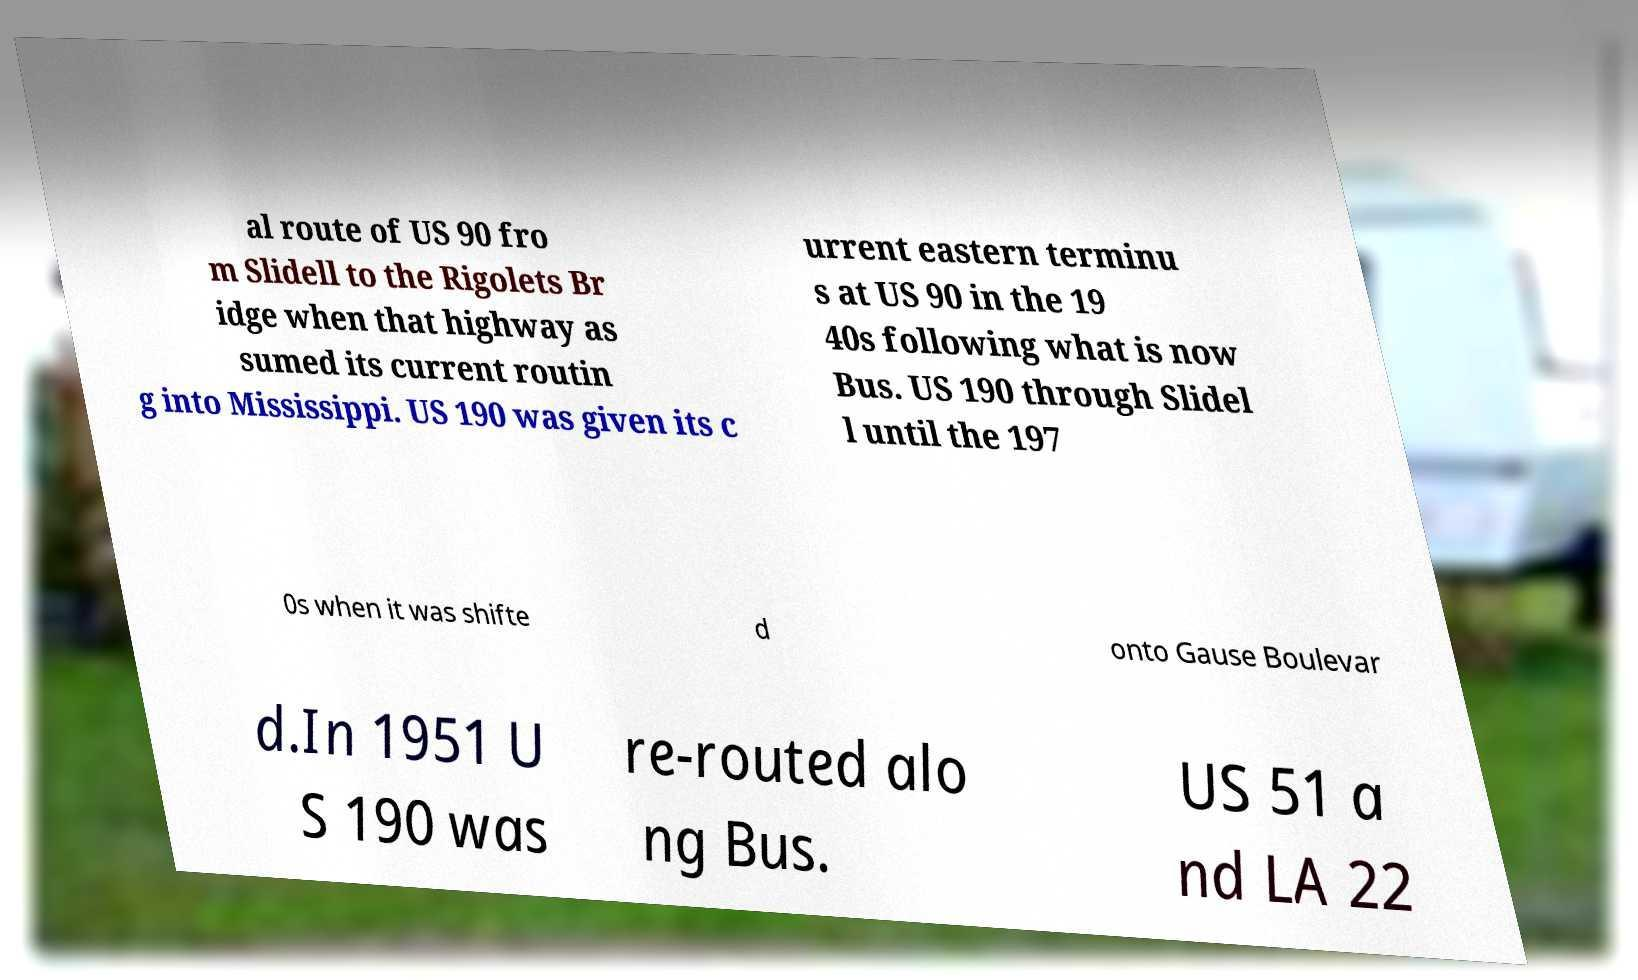Please read and relay the text visible in this image. What does it say? al route of US 90 fro m Slidell to the Rigolets Br idge when that highway as sumed its current routin g into Mississippi. US 190 was given its c urrent eastern terminu s at US 90 in the 19 40s following what is now Bus. US 190 through Slidel l until the 197 0s when it was shifte d onto Gause Boulevar d.In 1951 U S 190 was re-routed alo ng Bus. US 51 a nd LA 22 